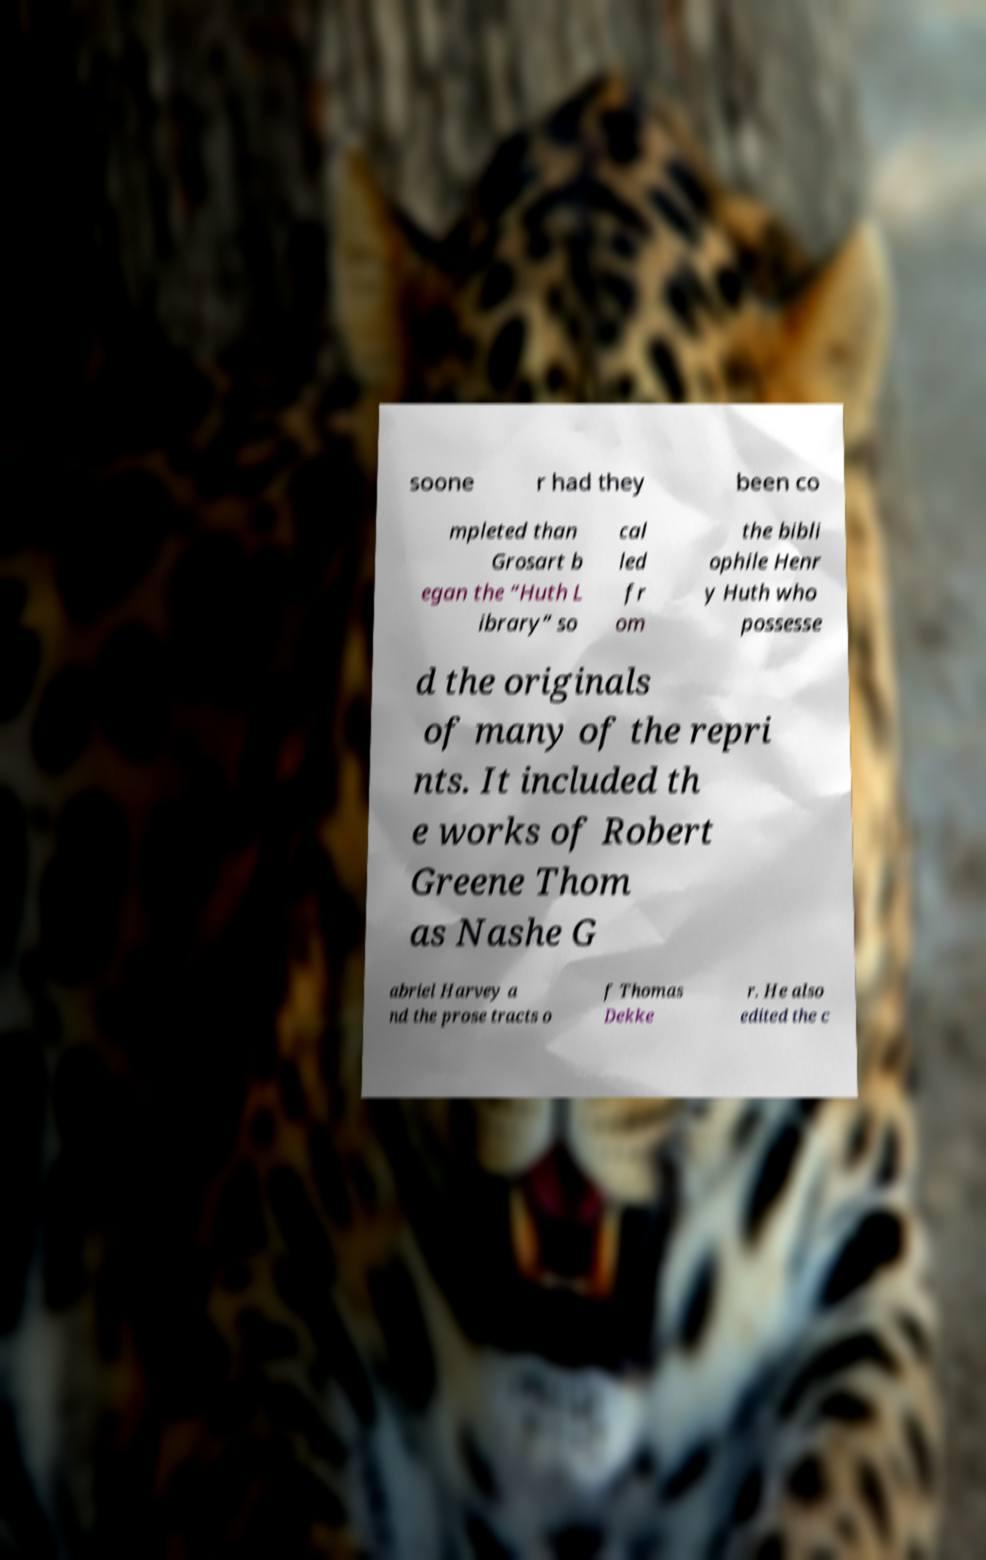Can you read and provide the text displayed in the image?This photo seems to have some interesting text. Can you extract and type it out for me? soone r had they been co mpleted than Grosart b egan the “Huth L ibrary” so cal led fr om the bibli ophile Henr y Huth who possesse d the originals of many of the repri nts. It included th e works of Robert Greene Thom as Nashe G abriel Harvey a nd the prose tracts o f Thomas Dekke r. He also edited the c 